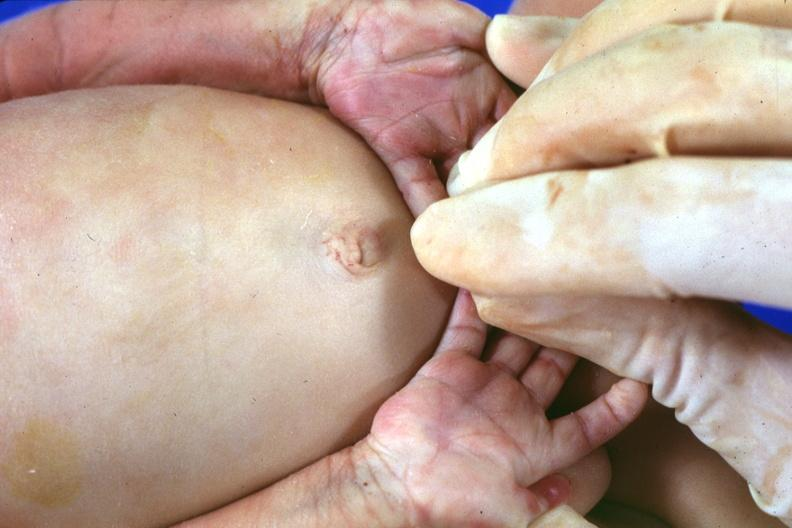s hand present?
Answer the question using a single word or phrase. Yes 